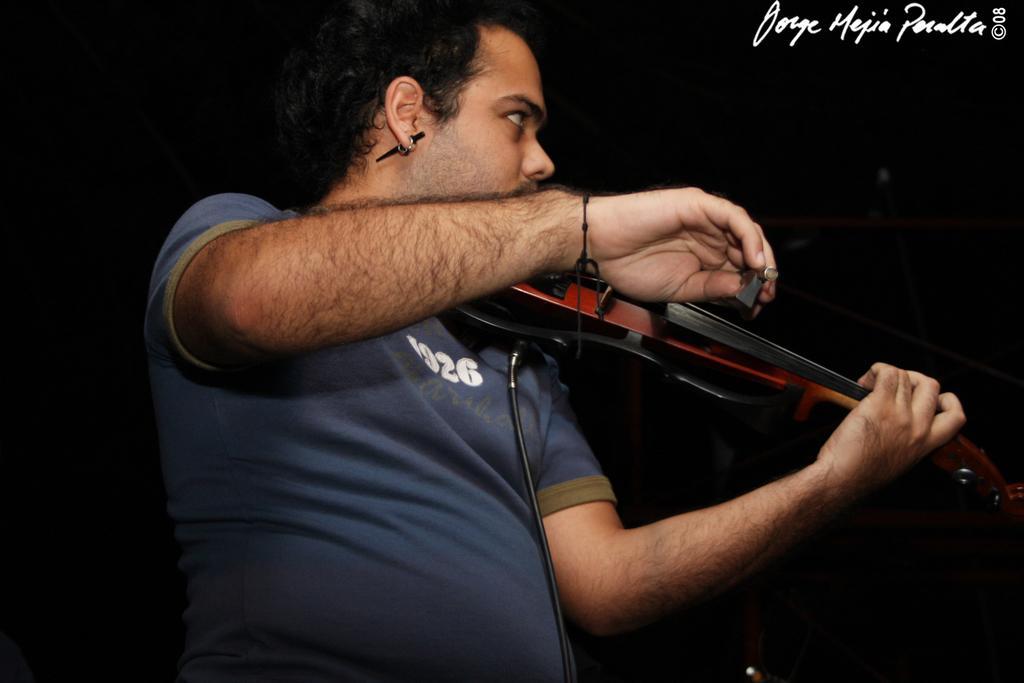Could you give a brief overview of what you see in this image? In this image I can see a man is holding a musical instrument. 